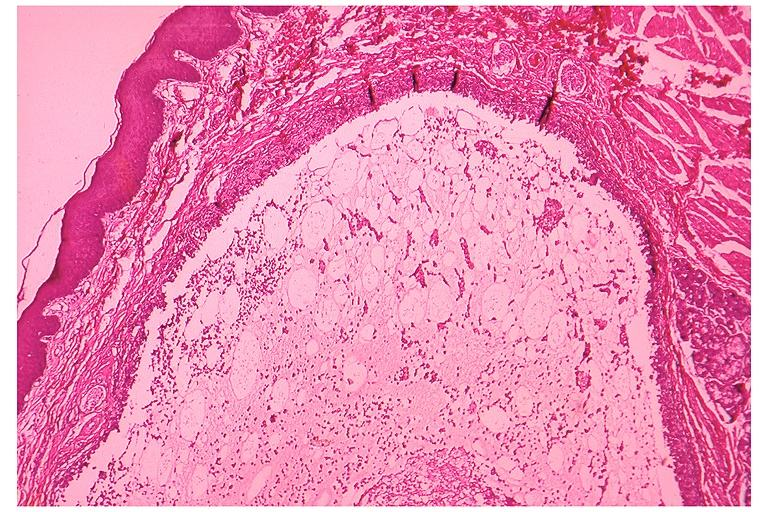does this image show mucocele?
Answer the question using a single word or phrase. Yes 